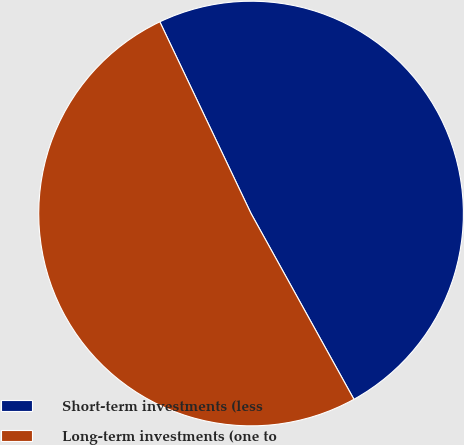Convert chart. <chart><loc_0><loc_0><loc_500><loc_500><pie_chart><fcel>Short-term investments (less<fcel>Long-term investments (one to<nl><fcel>49.02%<fcel>50.98%<nl></chart> 